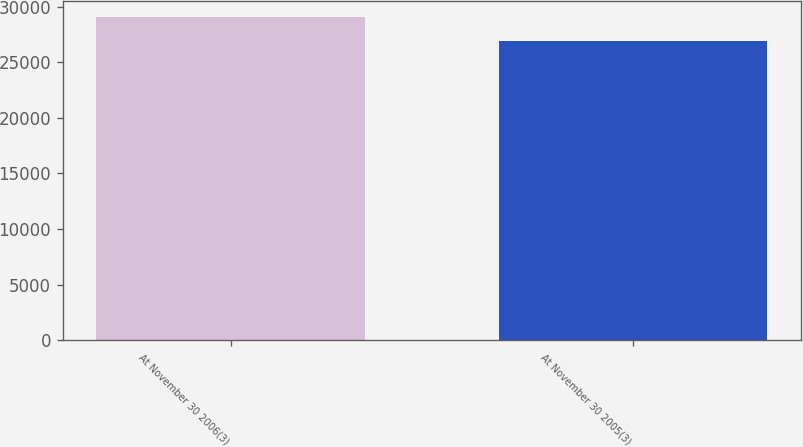<chart> <loc_0><loc_0><loc_500><loc_500><bar_chart><fcel>At November 30 2006(3)<fcel>At November 30 2005(3)<nl><fcel>29067<fcel>26944<nl></chart> 